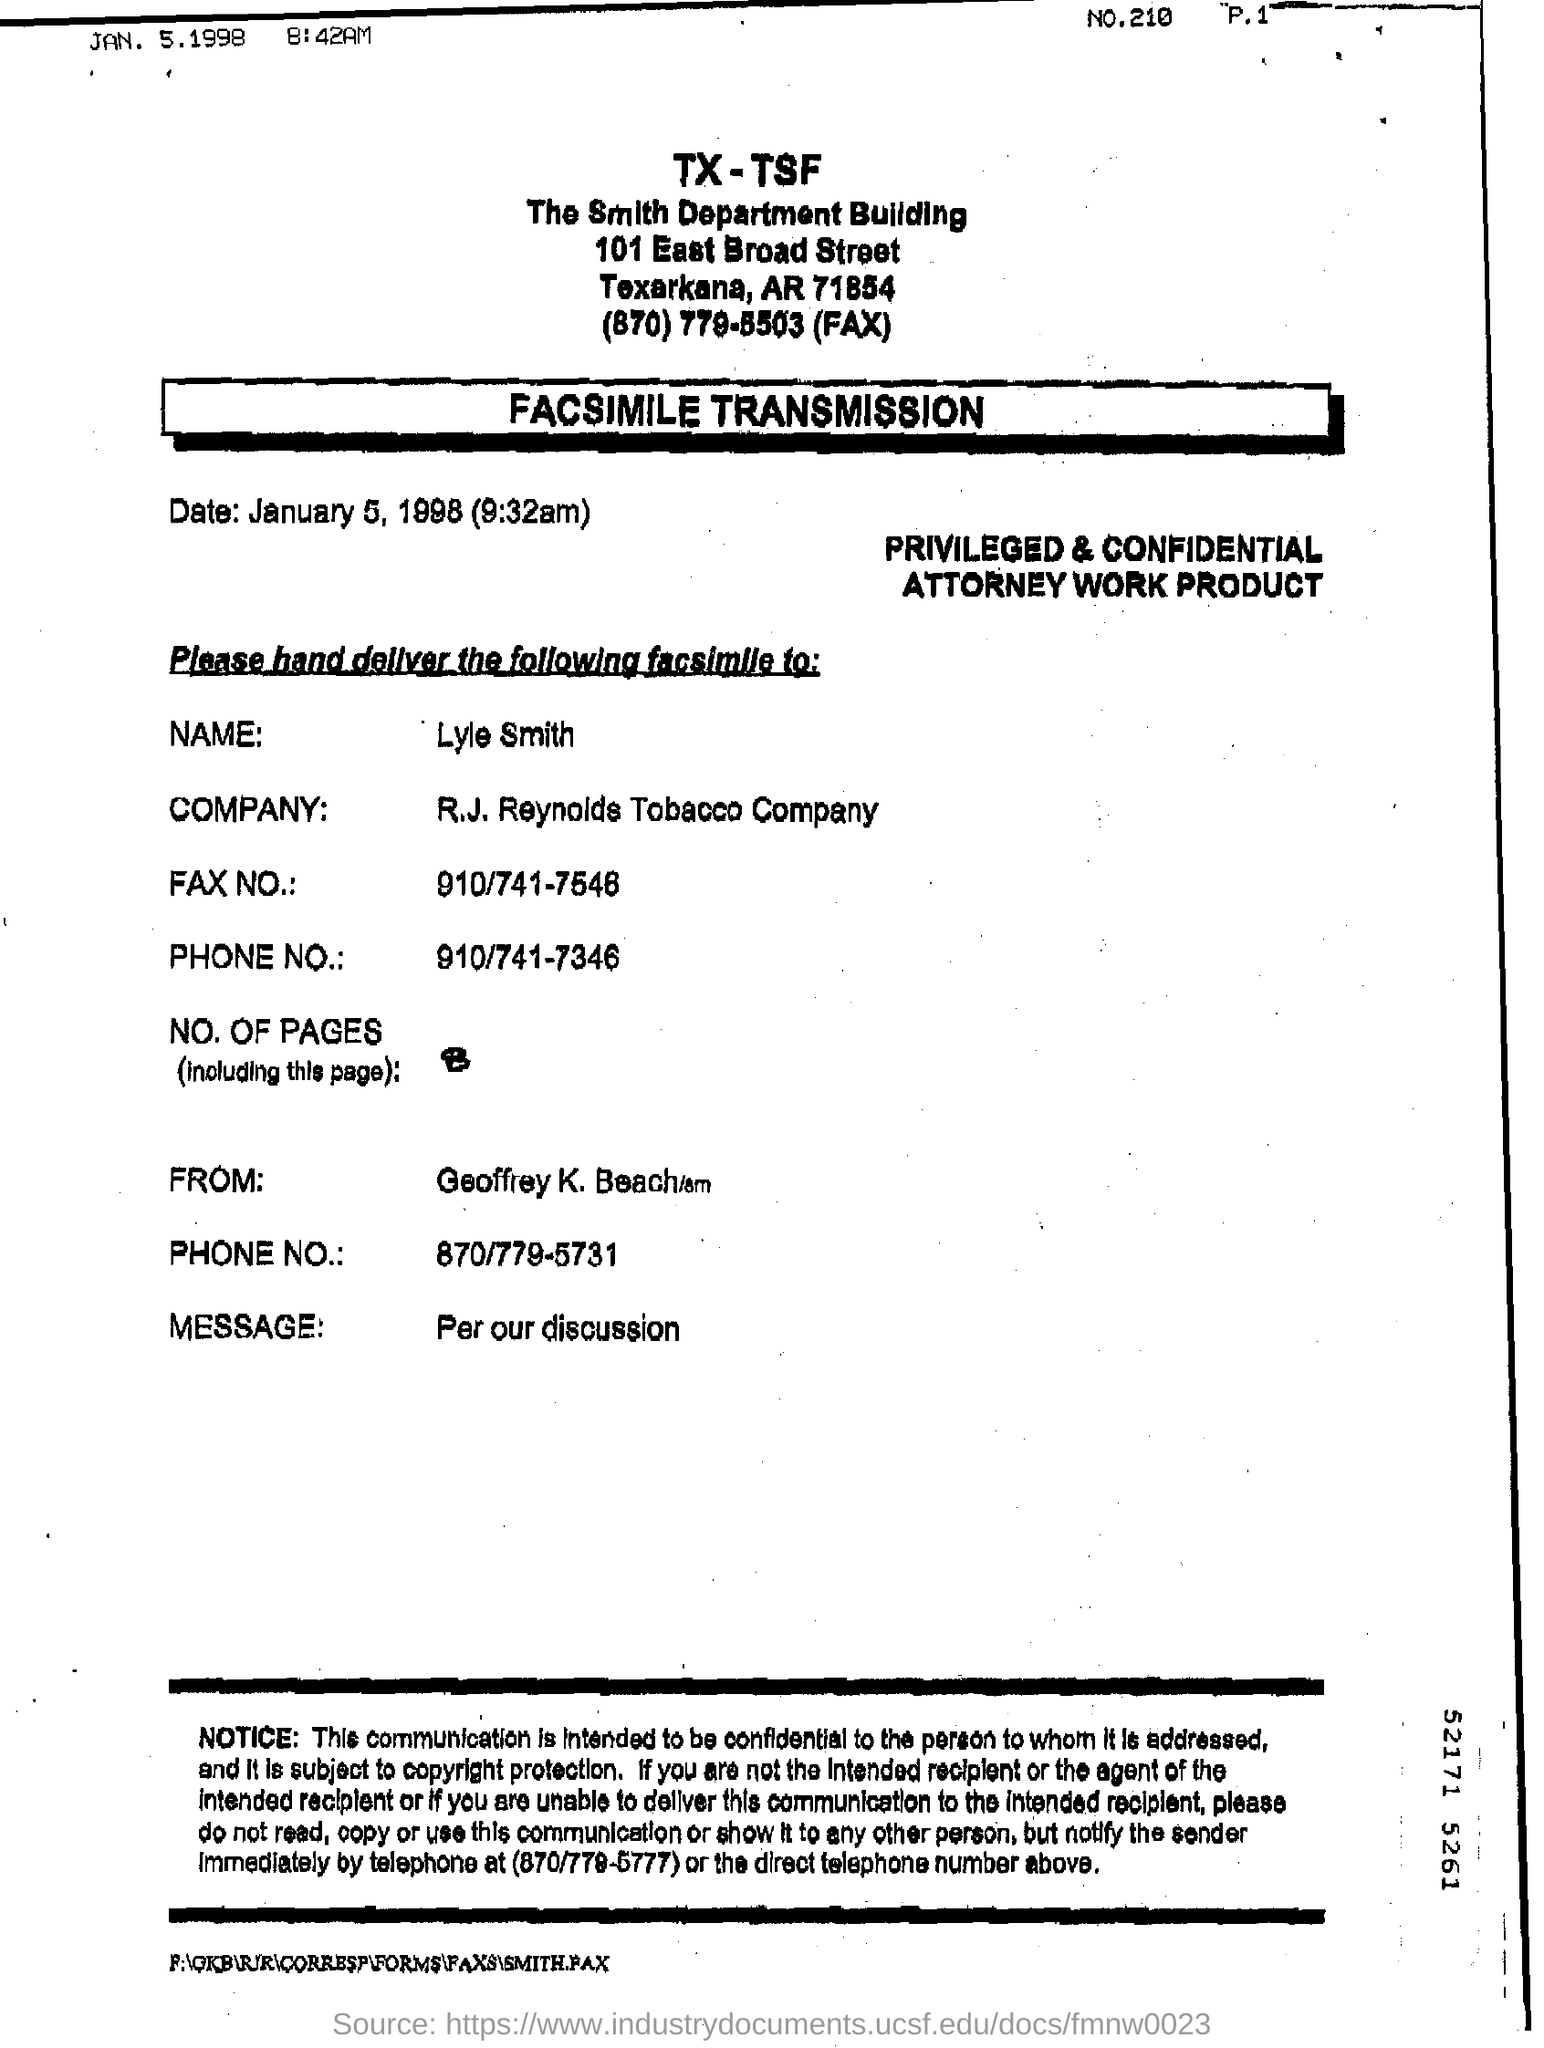Outline some significant characteristics in this image. On January 5, 1998, the date mentioned,... The document is addressed to Lyle Smith. 